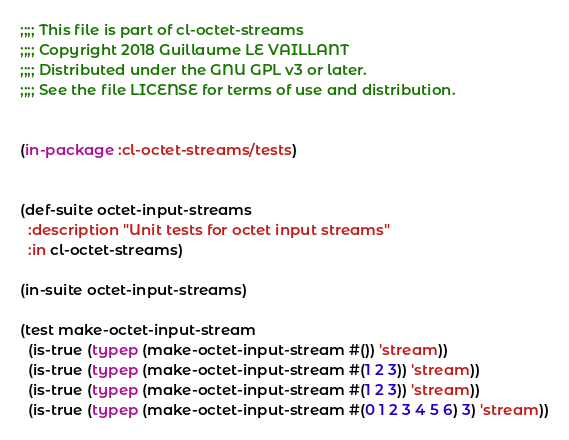Convert code to text. <code><loc_0><loc_0><loc_500><loc_500><_Lisp_>;;;; This file is part of cl-octet-streams
;;;; Copyright 2018 Guillaume LE VAILLANT
;;;; Distributed under the GNU GPL v3 or later.
;;;; See the file LICENSE for terms of use and distribution.


(in-package :cl-octet-streams/tests)


(def-suite octet-input-streams
  :description "Unit tests for octet input streams"
  :in cl-octet-streams)

(in-suite octet-input-streams)

(test make-octet-input-stream
  (is-true (typep (make-octet-input-stream #()) 'stream))
  (is-true (typep (make-octet-input-stream #(1 2 3)) 'stream))
  (is-true (typep (make-octet-input-stream #(1 2 3)) 'stream))
  (is-true (typep (make-octet-input-stream #(0 1 2 3 4 5 6) 3) 'stream))</code> 